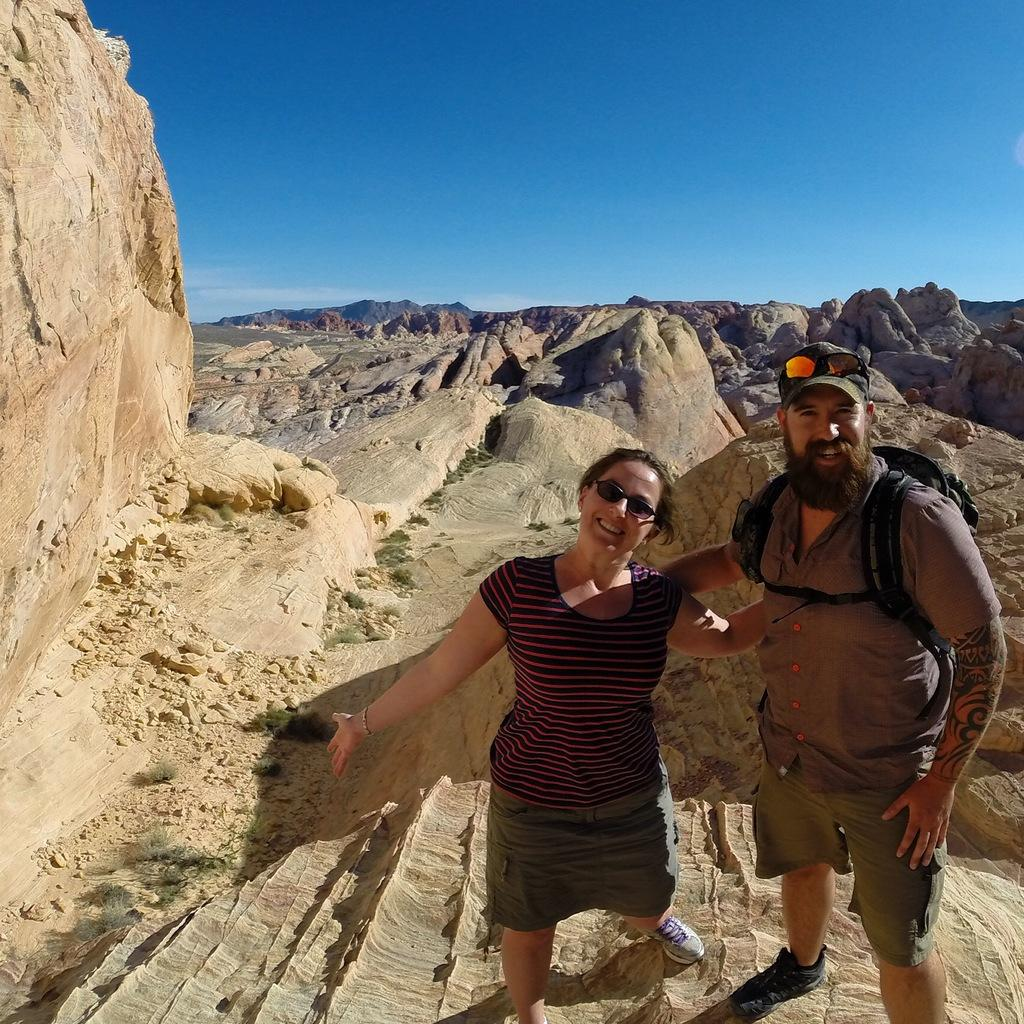Who are the people in the image? There is a woman and a man standing in the image. What are the expressions on their faces? Both the woman and the man are smiling. What is the man carrying on his back? The man is wearing a backpack. What type of natural elements can be seen in the image? There are rocks and stones, as well as plants visible in the image. What can be seen in the background of the image? The sky is visible in the background of the image. What type of treatment is the man receiving for his basketball-related injury in the image? There is no indication of a basketball-related injury or any treatment in the image. 